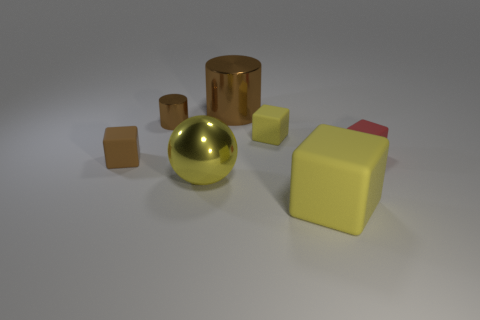Are there any tiny brown metallic cylinders in front of the big yellow matte object?
Give a very brief answer. No. Does the brown matte object have the same size as the red block?
Keep it short and to the point. Yes. What is the size of the brown thing that is the same shape as the small red object?
Give a very brief answer. Small. What material is the brown thing in front of the tiny matte thing to the right of the big yellow cube?
Offer a terse response. Rubber. Does the red thing have the same shape as the small yellow object?
Offer a terse response. Yes. How many blocks are behind the yellow ball and left of the red rubber cube?
Give a very brief answer. 2. Are there an equal number of brown matte things on the right side of the big yellow ball and large things that are to the left of the large cube?
Your answer should be compact. No. There is a rubber block that is on the left side of the large brown metallic object; is its size the same as the cube that is on the right side of the big matte object?
Provide a succinct answer. Yes. What material is the object that is both on the left side of the yellow metal sphere and behind the brown rubber cube?
Offer a very short reply. Metal. Is the number of red cubes less than the number of large objects?
Your answer should be very brief. Yes. 